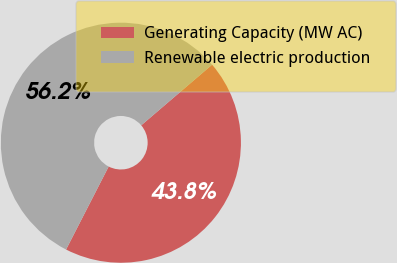Convert chart. <chart><loc_0><loc_0><loc_500><loc_500><pie_chart><fcel>Generating Capacity (MW AC)<fcel>Renewable electric production<nl><fcel>43.81%<fcel>56.19%<nl></chart> 